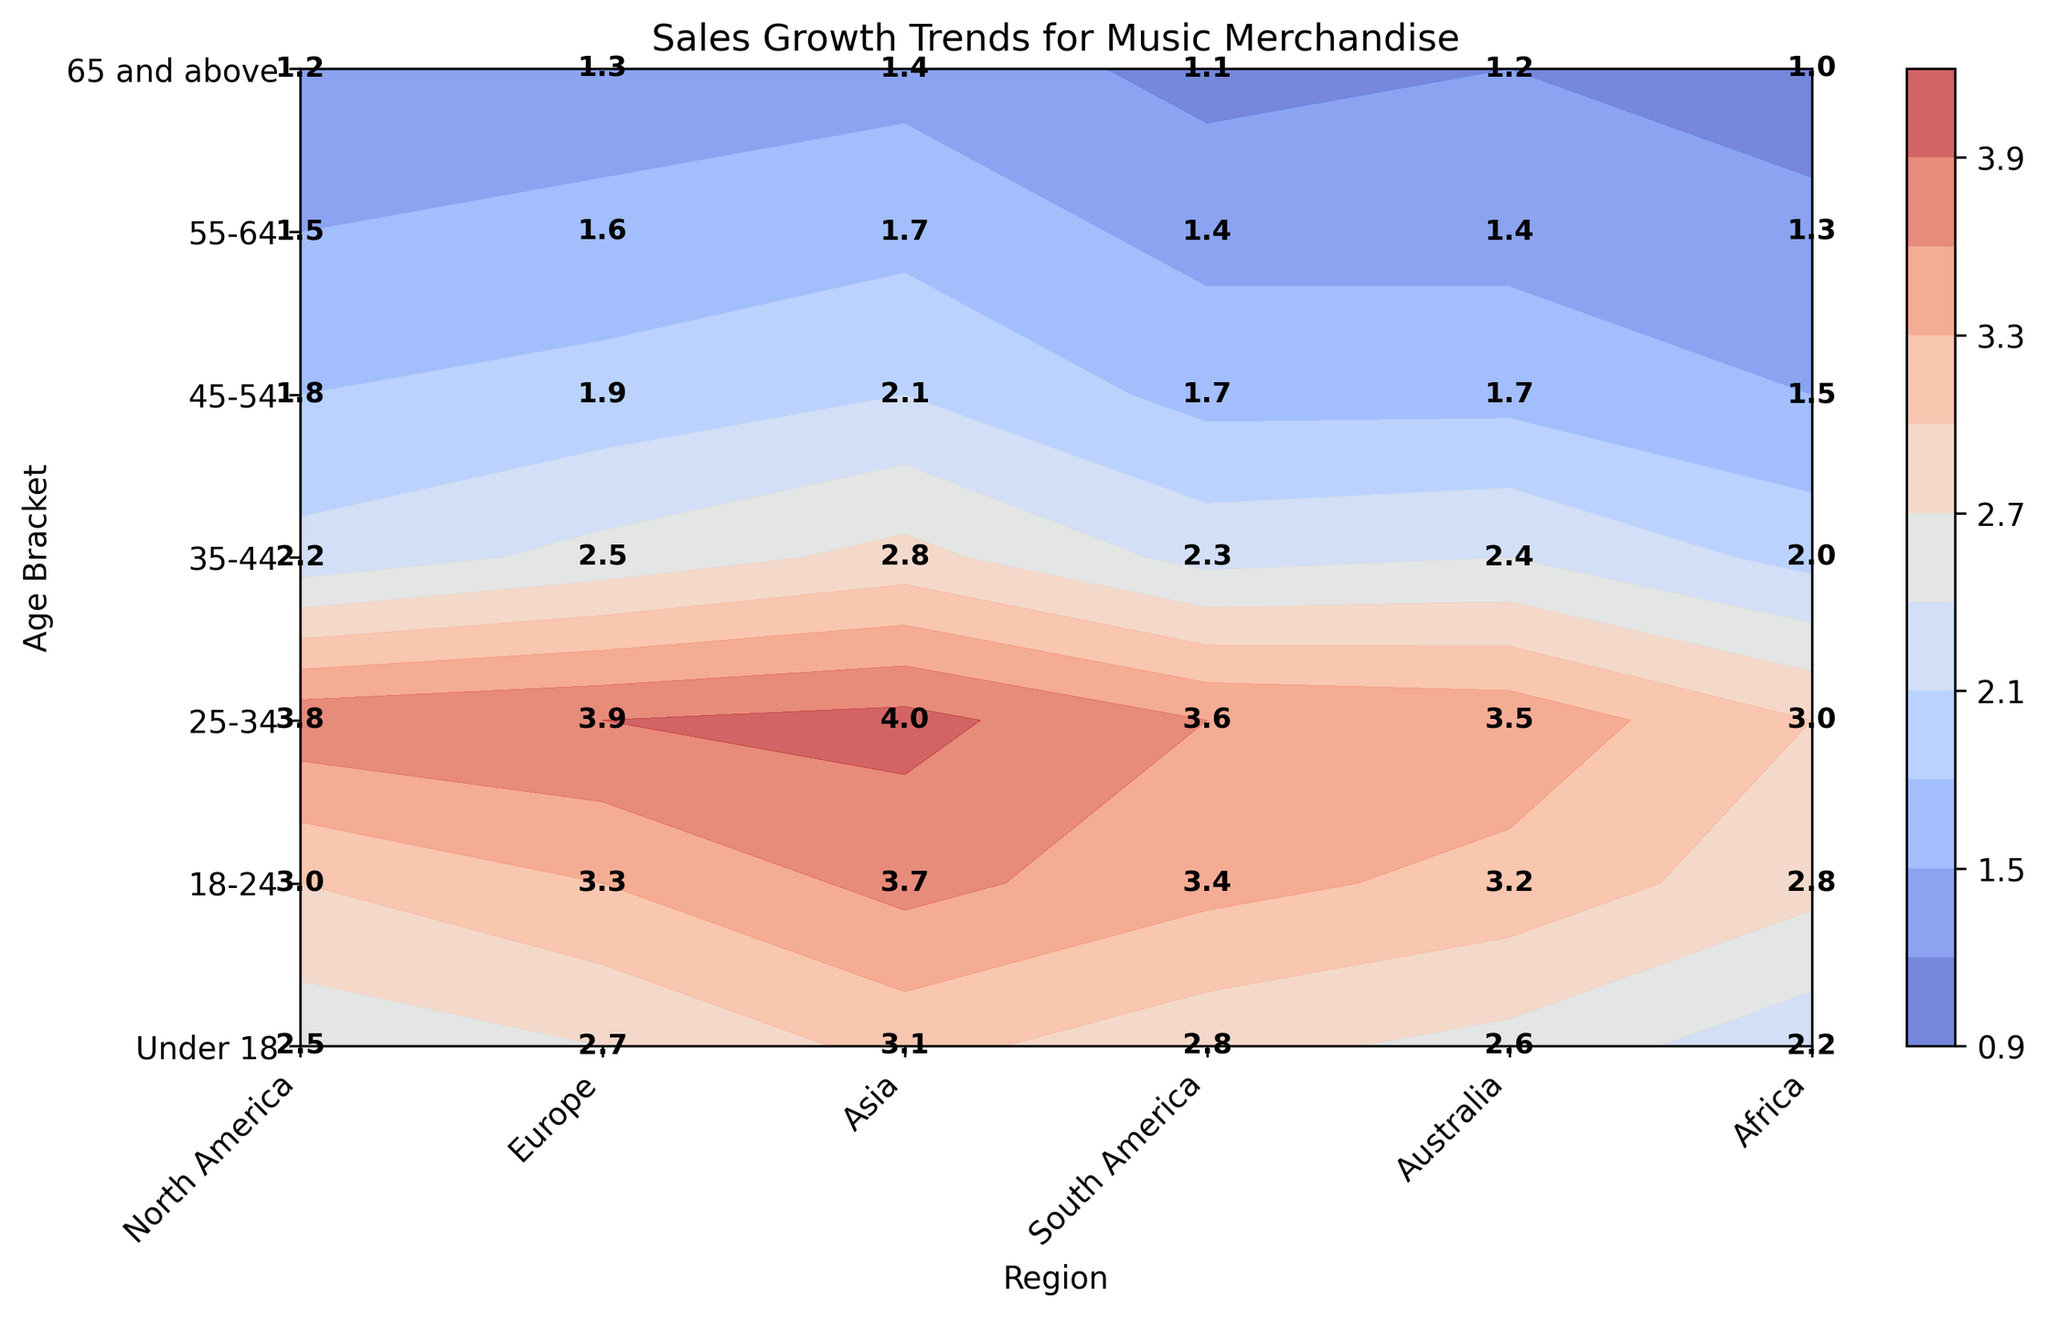What region has the highest sales growth for the 18-24 age bracket? Locate the region with the highest value in the 18-24 age row. It's in the "Asia" column with a value of 3.7.
Answer: Asia Which age bracket in Europe shows the second highest sales growth? Identify the highest value first, which is 3.9 for the 25-34 age bracket, then find the second highest, which is 3.3 for the 18-24 age bracket.
Answer: 18-24 What's the average sales growth for the age bracket 25-34 across all regions? Sum the sales growth values for the 25-34 bracket in all regions (3.8 + 3.9 + 4.0 + 3.6 + 3.5 + 3.0) and divide by the number of regions (6). (3.8 + 3.9 + 4.0 + 3.6 + 3.5 + 3.0) / 6 = 21.8 / 6 = 3.63
Answer: 3.63 Compare the sales growth between North America and Africa for the 55-64 age bracket. Which region has higher growth? Locate and compare the values for the 55-64 age bracket in both regions. North America has 1.5, and Africa has 1.3. North America's value is higher.
Answer: North America Which age bracket in Asia shows the lowest sales growth? Identify the smallest value in the "Asia" column. The smallest value is 1.4 for the 65 and above age bracket.
Answer: 65 and above What is the difference in sales growth between the highest and lowest age brackets in South America? Find the highest value, 3.6 (25-34), and the lowest value, 1.1 (65 and above), then subtract the lowest from the highest: 3.6 - 1.1 = 2.5.
Answer: 2.5 Which region shows the least variation in sales growth across age brackets? Compare the range (difference between max and min values) for each region. Africa has the smallest range: max 3.0 (25-34) - min 1.0 (65 and above) = 2.0 which is the smallest compared to other regions
Answer: Africa 